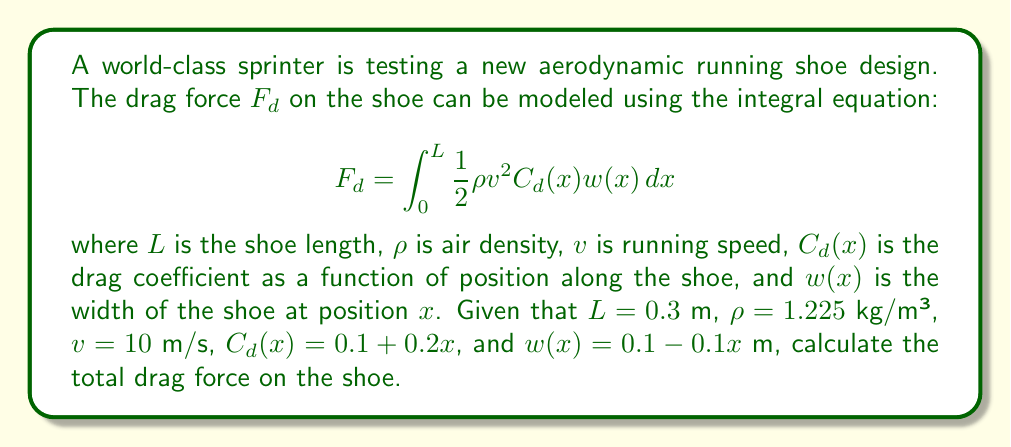Could you help me with this problem? To solve this problem, we need to evaluate the integral given in the drag force equation. Let's break it down step-by-step:

1) First, let's substitute the known values into the equation:
   $$F_d = \int_0^{0.3} \frac{1}{2} (1.225)(10^2) (0.1 + 0.2x) (0.1 - 0.1x) dx$$

2) Simplify the constant terms:
   $$F_d = 61.25 \int_0^{0.3} (0.1 + 0.2x) (0.1 - 0.1x) dx$$

3) Expand the product inside the integral:
   $$F_d = 61.25 \int_0^{0.3} (0.01 - 0.01x + 0.02x - 0.02x^2) dx$$

4) Simplify:
   $$F_d = 61.25 \int_0^{0.3} (0.01 + 0.01x - 0.02x^2) dx$$

5) Integrate term by term:
   $$F_d = 61.25 \left[0.01x + \frac{0.01x^2}{2} - \frac{0.02x^3}{3}\right]_0^{0.3}$$

6) Evaluate the integral at the limits:
   $$F_d = 61.25 \left[(0.01(0.3) + \frac{0.01(0.3)^2}{2} - \frac{0.02(0.3)^3}{3}) - (0)\right]$$

7) Calculate:
   $$F_d = 61.25 (0.003 + 0.00045 - 0.00018)$$
   $$F_d = 61.25 (0.00327)$$
   $$F_d = 0.20029375 \approx 0.2003\text{ N}$$

Therefore, the total drag force on the shoe is approximately 0.2003 N.
Answer: 0.2003 N 